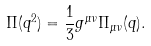Convert formula to latex. <formula><loc_0><loc_0><loc_500><loc_500>\Pi ( q ^ { 2 } ) = \frac { 1 } { 3 } g ^ { \mu \nu } \Pi _ { \mu \nu } ( q ) .</formula> 